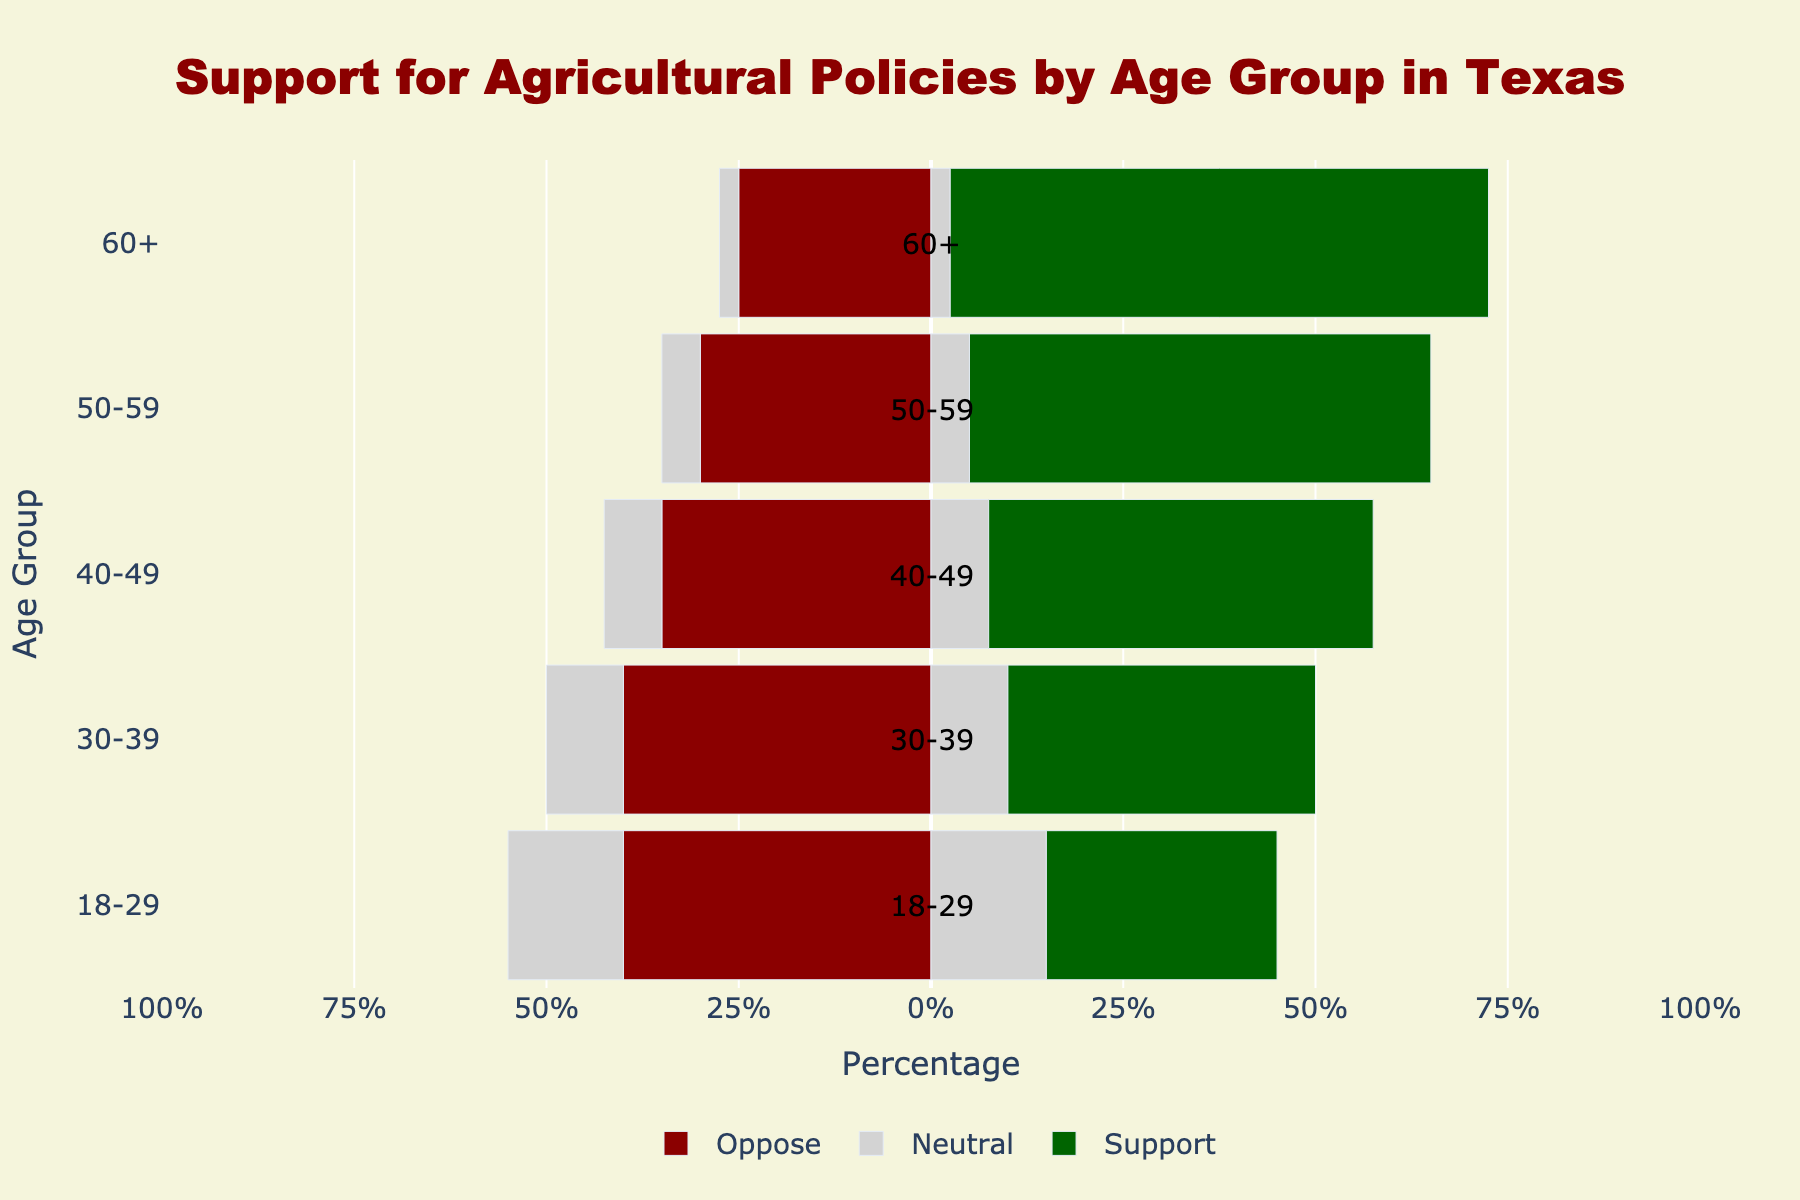What age group shows the highest level of strong support for agricultural policies? The green bar represent strong support and support combined, the 60+ age group has the highest combined value with the longest green bar reaching 70% of the respondents
Answer: 60+ Which age group has the highest level of opposition and strong opposition combined? Observe the length of the red bars for each age group, the 30-39 age group has the longest red bar, indicating it has the highest combined opposition level at 40% of respondents
Answer: 30-39 Between which two age groups is there the largest difference in neutral opinions? Compare the lengths of the gray bars of each age group; the 40-49 group has a 15% neutral response and the 60+ group has a 5% neutral response, showing the largest 10% difference
Answer: 40-49 and 60+ How does the level of support (including strong support and support) compare between the 18-29 and 50-59 age groups? The green bar for 50-59 is longer than 18-29, 60% for 50-59 age group compared to 30% for the 18-29 age group
Answer: The 50-59 age group shows more support than the 18-29 age group Which age group has the lowest percentage of neutral opinions? Look for the shortest gray bar across all age groups, which belongs to the 60+ group with only 5% of responses being neutral
Answer: 60+ What percentage of the 30-39 age group either opposes or strongly opposes the agricultural policies? The red bar for the 30-39 age group is 40%, indicating the proportion that either opposes or strongly opposes
Answer: 40% How do the level of strong support of the 18-29 and 60+ age groups compare? The portion of the green bar representing strong support in the 60+ age group (30%) is longer than the one in the 18-29 age group (10%)
Answer: The 60+ age group shows more strong support than the 18-29 age group Which age group has the most balanced (closest to equal) levels of support, opposition, and neutrality? The 30-39 group has close proportions in all categories with support at 40%, opposition at 40%, and neutrality at 20%, showing the most balance
Answer: 30-39 